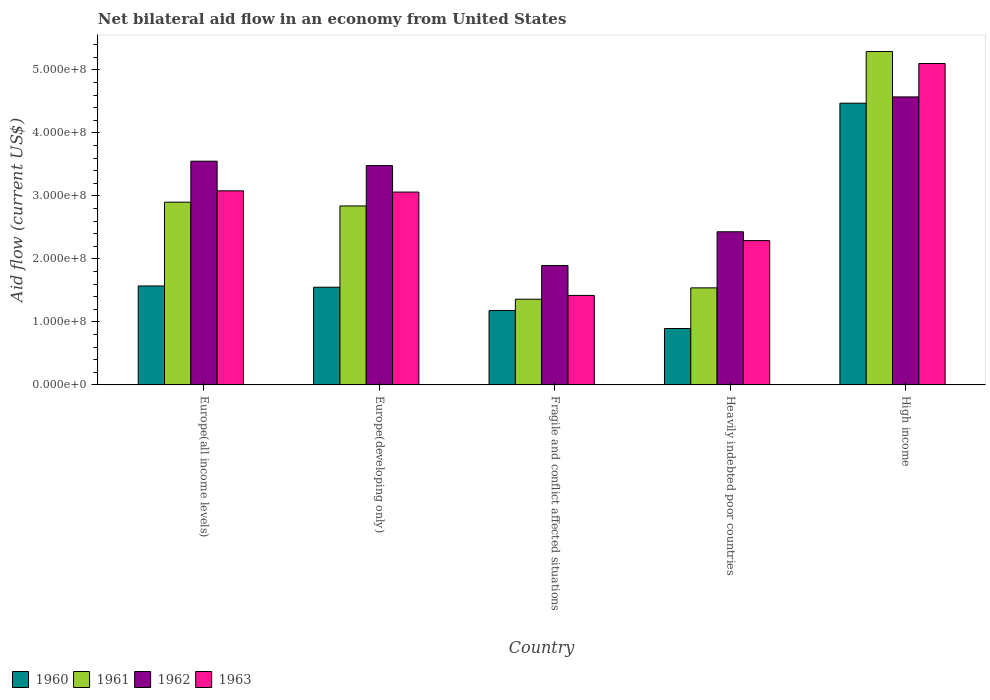How many different coloured bars are there?
Your response must be concise. 4. How many groups of bars are there?
Give a very brief answer. 5. Are the number of bars on each tick of the X-axis equal?
Ensure brevity in your answer.  Yes. How many bars are there on the 3rd tick from the right?
Offer a terse response. 4. What is the label of the 1st group of bars from the left?
Offer a terse response. Europe(all income levels). In how many cases, is the number of bars for a given country not equal to the number of legend labels?
Provide a succinct answer. 0. What is the net bilateral aid flow in 1960 in Fragile and conflict affected situations?
Offer a very short reply. 1.18e+08. Across all countries, what is the maximum net bilateral aid flow in 1961?
Your answer should be compact. 5.29e+08. Across all countries, what is the minimum net bilateral aid flow in 1963?
Your answer should be very brief. 1.42e+08. In which country was the net bilateral aid flow in 1961 maximum?
Offer a very short reply. High income. In which country was the net bilateral aid flow in 1960 minimum?
Keep it short and to the point. Heavily indebted poor countries. What is the total net bilateral aid flow in 1963 in the graph?
Give a very brief answer. 1.50e+09. What is the difference between the net bilateral aid flow in 1961 in Europe(all income levels) and that in Fragile and conflict affected situations?
Make the answer very short. 1.54e+08. What is the difference between the net bilateral aid flow in 1961 in Heavily indebted poor countries and the net bilateral aid flow in 1963 in High income?
Keep it short and to the point. -3.56e+08. What is the average net bilateral aid flow in 1962 per country?
Your response must be concise. 3.18e+08. What is the difference between the net bilateral aid flow of/in 1963 and net bilateral aid flow of/in 1962 in Heavily indebted poor countries?
Offer a terse response. -1.40e+07. What is the ratio of the net bilateral aid flow in 1961 in Fragile and conflict affected situations to that in Heavily indebted poor countries?
Offer a very short reply. 0.88. What is the difference between the highest and the second highest net bilateral aid flow in 1963?
Provide a short and direct response. 2.02e+08. What is the difference between the highest and the lowest net bilateral aid flow in 1961?
Give a very brief answer. 3.93e+08. Is it the case that in every country, the sum of the net bilateral aid flow in 1961 and net bilateral aid flow in 1960 is greater than the sum of net bilateral aid flow in 1963 and net bilateral aid flow in 1962?
Your answer should be very brief. No. What does the 1st bar from the right in Fragile and conflict affected situations represents?
Offer a terse response. 1963. Are all the bars in the graph horizontal?
Keep it short and to the point. No. What is the difference between two consecutive major ticks on the Y-axis?
Ensure brevity in your answer.  1.00e+08. Does the graph contain any zero values?
Offer a terse response. No. How many legend labels are there?
Make the answer very short. 4. How are the legend labels stacked?
Offer a very short reply. Horizontal. What is the title of the graph?
Provide a short and direct response. Net bilateral aid flow in an economy from United States. Does "1981" appear as one of the legend labels in the graph?
Offer a terse response. No. What is the label or title of the X-axis?
Make the answer very short. Country. What is the label or title of the Y-axis?
Provide a succinct answer. Aid flow (current US$). What is the Aid flow (current US$) of 1960 in Europe(all income levels)?
Your answer should be compact. 1.57e+08. What is the Aid flow (current US$) in 1961 in Europe(all income levels)?
Ensure brevity in your answer.  2.90e+08. What is the Aid flow (current US$) of 1962 in Europe(all income levels)?
Keep it short and to the point. 3.55e+08. What is the Aid flow (current US$) of 1963 in Europe(all income levels)?
Offer a terse response. 3.08e+08. What is the Aid flow (current US$) in 1960 in Europe(developing only)?
Provide a short and direct response. 1.55e+08. What is the Aid flow (current US$) in 1961 in Europe(developing only)?
Your response must be concise. 2.84e+08. What is the Aid flow (current US$) in 1962 in Europe(developing only)?
Your response must be concise. 3.48e+08. What is the Aid flow (current US$) of 1963 in Europe(developing only)?
Offer a terse response. 3.06e+08. What is the Aid flow (current US$) in 1960 in Fragile and conflict affected situations?
Provide a succinct answer. 1.18e+08. What is the Aid flow (current US$) in 1961 in Fragile and conflict affected situations?
Keep it short and to the point. 1.36e+08. What is the Aid flow (current US$) in 1962 in Fragile and conflict affected situations?
Your response must be concise. 1.90e+08. What is the Aid flow (current US$) in 1963 in Fragile and conflict affected situations?
Give a very brief answer. 1.42e+08. What is the Aid flow (current US$) in 1960 in Heavily indebted poor countries?
Provide a succinct answer. 8.95e+07. What is the Aid flow (current US$) of 1961 in Heavily indebted poor countries?
Your response must be concise. 1.54e+08. What is the Aid flow (current US$) of 1962 in Heavily indebted poor countries?
Offer a very short reply. 2.43e+08. What is the Aid flow (current US$) in 1963 in Heavily indebted poor countries?
Offer a very short reply. 2.29e+08. What is the Aid flow (current US$) in 1960 in High income?
Keep it short and to the point. 4.47e+08. What is the Aid flow (current US$) in 1961 in High income?
Ensure brevity in your answer.  5.29e+08. What is the Aid flow (current US$) in 1962 in High income?
Give a very brief answer. 4.57e+08. What is the Aid flow (current US$) of 1963 in High income?
Your answer should be very brief. 5.10e+08. Across all countries, what is the maximum Aid flow (current US$) of 1960?
Keep it short and to the point. 4.47e+08. Across all countries, what is the maximum Aid flow (current US$) in 1961?
Keep it short and to the point. 5.29e+08. Across all countries, what is the maximum Aid flow (current US$) of 1962?
Provide a short and direct response. 4.57e+08. Across all countries, what is the maximum Aid flow (current US$) of 1963?
Your response must be concise. 5.10e+08. Across all countries, what is the minimum Aid flow (current US$) in 1960?
Offer a very short reply. 8.95e+07. Across all countries, what is the minimum Aid flow (current US$) in 1961?
Provide a succinct answer. 1.36e+08. Across all countries, what is the minimum Aid flow (current US$) in 1962?
Ensure brevity in your answer.  1.90e+08. Across all countries, what is the minimum Aid flow (current US$) of 1963?
Provide a short and direct response. 1.42e+08. What is the total Aid flow (current US$) of 1960 in the graph?
Give a very brief answer. 9.67e+08. What is the total Aid flow (current US$) in 1961 in the graph?
Your response must be concise. 1.39e+09. What is the total Aid flow (current US$) of 1962 in the graph?
Keep it short and to the point. 1.59e+09. What is the total Aid flow (current US$) of 1963 in the graph?
Your answer should be compact. 1.50e+09. What is the difference between the Aid flow (current US$) of 1962 in Europe(all income levels) and that in Europe(developing only)?
Ensure brevity in your answer.  7.00e+06. What is the difference between the Aid flow (current US$) in 1963 in Europe(all income levels) and that in Europe(developing only)?
Give a very brief answer. 2.00e+06. What is the difference between the Aid flow (current US$) of 1960 in Europe(all income levels) and that in Fragile and conflict affected situations?
Offer a terse response. 3.90e+07. What is the difference between the Aid flow (current US$) of 1961 in Europe(all income levels) and that in Fragile and conflict affected situations?
Provide a succinct answer. 1.54e+08. What is the difference between the Aid flow (current US$) in 1962 in Europe(all income levels) and that in Fragile and conflict affected situations?
Your answer should be compact. 1.66e+08. What is the difference between the Aid flow (current US$) in 1963 in Europe(all income levels) and that in Fragile and conflict affected situations?
Offer a terse response. 1.66e+08. What is the difference between the Aid flow (current US$) of 1960 in Europe(all income levels) and that in Heavily indebted poor countries?
Keep it short and to the point. 6.75e+07. What is the difference between the Aid flow (current US$) in 1961 in Europe(all income levels) and that in Heavily indebted poor countries?
Your answer should be very brief. 1.36e+08. What is the difference between the Aid flow (current US$) in 1962 in Europe(all income levels) and that in Heavily indebted poor countries?
Give a very brief answer. 1.12e+08. What is the difference between the Aid flow (current US$) of 1963 in Europe(all income levels) and that in Heavily indebted poor countries?
Provide a succinct answer. 7.90e+07. What is the difference between the Aid flow (current US$) of 1960 in Europe(all income levels) and that in High income?
Keep it short and to the point. -2.90e+08. What is the difference between the Aid flow (current US$) of 1961 in Europe(all income levels) and that in High income?
Give a very brief answer. -2.39e+08. What is the difference between the Aid flow (current US$) of 1962 in Europe(all income levels) and that in High income?
Provide a succinct answer. -1.02e+08. What is the difference between the Aid flow (current US$) in 1963 in Europe(all income levels) and that in High income?
Your answer should be compact. -2.02e+08. What is the difference between the Aid flow (current US$) in 1960 in Europe(developing only) and that in Fragile and conflict affected situations?
Your answer should be compact. 3.70e+07. What is the difference between the Aid flow (current US$) of 1961 in Europe(developing only) and that in Fragile and conflict affected situations?
Ensure brevity in your answer.  1.48e+08. What is the difference between the Aid flow (current US$) of 1962 in Europe(developing only) and that in Fragile and conflict affected situations?
Your response must be concise. 1.58e+08. What is the difference between the Aid flow (current US$) in 1963 in Europe(developing only) and that in Fragile and conflict affected situations?
Give a very brief answer. 1.64e+08. What is the difference between the Aid flow (current US$) of 1960 in Europe(developing only) and that in Heavily indebted poor countries?
Provide a succinct answer. 6.55e+07. What is the difference between the Aid flow (current US$) of 1961 in Europe(developing only) and that in Heavily indebted poor countries?
Give a very brief answer. 1.30e+08. What is the difference between the Aid flow (current US$) in 1962 in Europe(developing only) and that in Heavily indebted poor countries?
Your response must be concise. 1.05e+08. What is the difference between the Aid flow (current US$) in 1963 in Europe(developing only) and that in Heavily indebted poor countries?
Give a very brief answer. 7.70e+07. What is the difference between the Aid flow (current US$) in 1960 in Europe(developing only) and that in High income?
Keep it short and to the point. -2.92e+08. What is the difference between the Aid flow (current US$) of 1961 in Europe(developing only) and that in High income?
Give a very brief answer. -2.45e+08. What is the difference between the Aid flow (current US$) of 1962 in Europe(developing only) and that in High income?
Your answer should be compact. -1.09e+08. What is the difference between the Aid flow (current US$) in 1963 in Europe(developing only) and that in High income?
Your answer should be very brief. -2.04e+08. What is the difference between the Aid flow (current US$) in 1960 in Fragile and conflict affected situations and that in Heavily indebted poor countries?
Your response must be concise. 2.85e+07. What is the difference between the Aid flow (current US$) of 1961 in Fragile and conflict affected situations and that in Heavily indebted poor countries?
Ensure brevity in your answer.  -1.80e+07. What is the difference between the Aid flow (current US$) of 1962 in Fragile and conflict affected situations and that in Heavily indebted poor countries?
Provide a succinct answer. -5.35e+07. What is the difference between the Aid flow (current US$) in 1963 in Fragile and conflict affected situations and that in Heavily indebted poor countries?
Provide a short and direct response. -8.70e+07. What is the difference between the Aid flow (current US$) in 1960 in Fragile and conflict affected situations and that in High income?
Provide a succinct answer. -3.29e+08. What is the difference between the Aid flow (current US$) in 1961 in Fragile and conflict affected situations and that in High income?
Keep it short and to the point. -3.93e+08. What is the difference between the Aid flow (current US$) in 1962 in Fragile and conflict affected situations and that in High income?
Make the answer very short. -2.68e+08. What is the difference between the Aid flow (current US$) in 1963 in Fragile and conflict affected situations and that in High income?
Offer a very short reply. -3.68e+08. What is the difference between the Aid flow (current US$) in 1960 in Heavily indebted poor countries and that in High income?
Make the answer very short. -3.57e+08. What is the difference between the Aid flow (current US$) of 1961 in Heavily indebted poor countries and that in High income?
Your response must be concise. -3.75e+08. What is the difference between the Aid flow (current US$) of 1962 in Heavily indebted poor countries and that in High income?
Provide a succinct answer. -2.14e+08. What is the difference between the Aid flow (current US$) of 1963 in Heavily indebted poor countries and that in High income?
Provide a succinct answer. -2.81e+08. What is the difference between the Aid flow (current US$) of 1960 in Europe(all income levels) and the Aid flow (current US$) of 1961 in Europe(developing only)?
Offer a very short reply. -1.27e+08. What is the difference between the Aid flow (current US$) in 1960 in Europe(all income levels) and the Aid flow (current US$) in 1962 in Europe(developing only)?
Ensure brevity in your answer.  -1.91e+08. What is the difference between the Aid flow (current US$) of 1960 in Europe(all income levels) and the Aid flow (current US$) of 1963 in Europe(developing only)?
Your answer should be very brief. -1.49e+08. What is the difference between the Aid flow (current US$) in 1961 in Europe(all income levels) and the Aid flow (current US$) in 1962 in Europe(developing only)?
Your answer should be compact. -5.80e+07. What is the difference between the Aid flow (current US$) of 1961 in Europe(all income levels) and the Aid flow (current US$) of 1963 in Europe(developing only)?
Your response must be concise. -1.60e+07. What is the difference between the Aid flow (current US$) of 1962 in Europe(all income levels) and the Aid flow (current US$) of 1963 in Europe(developing only)?
Your response must be concise. 4.90e+07. What is the difference between the Aid flow (current US$) in 1960 in Europe(all income levels) and the Aid flow (current US$) in 1961 in Fragile and conflict affected situations?
Keep it short and to the point. 2.10e+07. What is the difference between the Aid flow (current US$) of 1960 in Europe(all income levels) and the Aid flow (current US$) of 1962 in Fragile and conflict affected situations?
Your answer should be compact. -3.25e+07. What is the difference between the Aid flow (current US$) in 1960 in Europe(all income levels) and the Aid flow (current US$) in 1963 in Fragile and conflict affected situations?
Offer a very short reply. 1.50e+07. What is the difference between the Aid flow (current US$) in 1961 in Europe(all income levels) and the Aid flow (current US$) in 1962 in Fragile and conflict affected situations?
Keep it short and to the point. 1.00e+08. What is the difference between the Aid flow (current US$) of 1961 in Europe(all income levels) and the Aid flow (current US$) of 1963 in Fragile and conflict affected situations?
Provide a succinct answer. 1.48e+08. What is the difference between the Aid flow (current US$) in 1962 in Europe(all income levels) and the Aid flow (current US$) in 1963 in Fragile and conflict affected situations?
Offer a terse response. 2.13e+08. What is the difference between the Aid flow (current US$) in 1960 in Europe(all income levels) and the Aid flow (current US$) in 1961 in Heavily indebted poor countries?
Provide a succinct answer. 3.00e+06. What is the difference between the Aid flow (current US$) in 1960 in Europe(all income levels) and the Aid flow (current US$) in 1962 in Heavily indebted poor countries?
Ensure brevity in your answer.  -8.60e+07. What is the difference between the Aid flow (current US$) of 1960 in Europe(all income levels) and the Aid flow (current US$) of 1963 in Heavily indebted poor countries?
Your response must be concise. -7.20e+07. What is the difference between the Aid flow (current US$) of 1961 in Europe(all income levels) and the Aid flow (current US$) of 1962 in Heavily indebted poor countries?
Your response must be concise. 4.70e+07. What is the difference between the Aid flow (current US$) in 1961 in Europe(all income levels) and the Aid flow (current US$) in 1963 in Heavily indebted poor countries?
Your response must be concise. 6.10e+07. What is the difference between the Aid flow (current US$) in 1962 in Europe(all income levels) and the Aid flow (current US$) in 1963 in Heavily indebted poor countries?
Give a very brief answer. 1.26e+08. What is the difference between the Aid flow (current US$) of 1960 in Europe(all income levels) and the Aid flow (current US$) of 1961 in High income?
Give a very brief answer. -3.72e+08. What is the difference between the Aid flow (current US$) of 1960 in Europe(all income levels) and the Aid flow (current US$) of 1962 in High income?
Give a very brief answer. -3.00e+08. What is the difference between the Aid flow (current US$) in 1960 in Europe(all income levels) and the Aid flow (current US$) in 1963 in High income?
Keep it short and to the point. -3.53e+08. What is the difference between the Aid flow (current US$) of 1961 in Europe(all income levels) and the Aid flow (current US$) of 1962 in High income?
Ensure brevity in your answer.  -1.67e+08. What is the difference between the Aid flow (current US$) in 1961 in Europe(all income levels) and the Aid flow (current US$) in 1963 in High income?
Keep it short and to the point. -2.20e+08. What is the difference between the Aid flow (current US$) in 1962 in Europe(all income levels) and the Aid flow (current US$) in 1963 in High income?
Offer a very short reply. -1.55e+08. What is the difference between the Aid flow (current US$) in 1960 in Europe(developing only) and the Aid flow (current US$) in 1961 in Fragile and conflict affected situations?
Give a very brief answer. 1.90e+07. What is the difference between the Aid flow (current US$) of 1960 in Europe(developing only) and the Aid flow (current US$) of 1962 in Fragile and conflict affected situations?
Provide a short and direct response. -3.45e+07. What is the difference between the Aid flow (current US$) in 1960 in Europe(developing only) and the Aid flow (current US$) in 1963 in Fragile and conflict affected situations?
Provide a short and direct response. 1.30e+07. What is the difference between the Aid flow (current US$) in 1961 in Europe(developing only) and the Aid flow (current US$) in 1962 in Fragile and conflict affected situations?
Provide a succinct answer. 9.45e+07. What is the difference between the Aid flow (current US$) in 1961 in Europe(developing only) and the Aid flow (current US$) in 1963 in Fragile and conflict affected situations?
Ensure brevity in your answer.  1.42e+08. What is the difference between the Aid flow (current US$) of 1962 in Europe(developing only) and the Aid flow (current US$) of 1963 in Fragile and conflict affected situations?
Offer a terse response. 2.06e+08. What is the difference between the Aid flow (current US$) in 1960 in Europe(developing only) and the Aid flow (current US$) in 1962 in Heavily indebted poor countries?
Your answer should be very brief. -8.80e+07. What is the difference between the Aid flow (current US$) in 1960 in Europe(developing only) and the Aid flow (current US$) in 1963 in Heavily indebted poor countries?
Offer a terse response. -7.40e+07. What is the difference between the Aid flow (current US$) of 1961 in Europe(developing only) and the Aid flow (current US$) of 1962 in Heavily indebted poor countries?
Offer a terse response. 4.10e+07. What is the difference between the Aid flow (current US$) in 1961 in Europe(developing only) and the Aid flow (current US$) in 1963 in Heavily indebted poor countries?
Offer a terse response. 5.50e+07. What is the difference between the Aid flow (current US$) of 1962 in Europe(developing only) and the Aid flow (current US$) of 1963 in Heavily indebted poor countries?
Give a very brief answer. 1.19e+08. What is the difference between the Aid flow (current US$) in 1960 in Europe(developing only) and the Aid flow (current US$) in 1961 in High income?
Your answer should be compact. -3.74e+08. What is the difference between the Aid flow (current US$) in 1960 in Europe(developing only) and the Aid flow (current US$) in 1962 in High income?
Your answer should be compact. -3.02e+08. What is the difference between the Aid flow (current US$) of 1960 in Europe(developing only) and the Aid flow (current US$) of 1963 in High income?
Your answer should be very brief. -3.55e+08. What is the difference between the Aid flow (current US$) in 1961 in Europe(developing only) and the Aid flow (current US$) in 1962 in High income?
Give a very brief answer. -1.73e+08. What is the difference between the Aid flow (current US$) in 1961 in Europe(developing only) and the Aid flow (current US$) in 1963 in High income?
Give a very brief answer. -2.26e+08. What is the difference between the Aid flow (current US$) in 1962 in Europe(developing only) and the Aid flow (current US$) in 1963 in High income?
Ensure brevity in your answer.  -1.62e+08. What is the difference between the Aid flow (current US$) of 1960 in Fragile and conflict affected situations and the Aid flow (current US$) of 1961 in Heavily indebted poor countries?
Offer a very short reply. -3.60e+07. What is the difference between the Aid flow (current US$) in 1960 in Fragile and conflict affected situations and the Aid flow (current US$) in 1962 in Heavily indebted poor countries?
Your answer should be very brief. -1.25e+08. What is the difference between the Aid flow (current US$) in 1960 in Fragile and conflict affected situations and the Aid flow (current US$) in 1963 in Heavily indebted poor countries?
Give a very brief answer. -1.11e+08. What is the difference between the Aid flow (current US$) of 1961 in Fragile and conflict affected situations and the Aid flow (current US$) of 1962 in Heavily indebted poor countries?
Give a very brief answer. -1.07e+08. What is the difference between the Aid flow (current US$) in 1961 in Fragile and conflict affected situations and the Aid flow (current US$) in 1963 in Heavily indebted poor countries?
Your answer should be very brief. -9.30e+07. What is the difference between the Aid flow (current US$) of 1962 in Fragile and conflict affected situations and the Aid flow (current US$) of 1963 in Heavily indebted poor countries?
Ensure brevity in your answer.  -3.95e+07. What is the difference between the Aid flow (current US$) in 1960 in Fragile and conflict affected situations and the Aid flow (current US$) in 1961 in High income?
Give a very brief answer. -4.11e+08. What is the difference between the Aid flow (current US$) in 1960 in Fragile and conflict affected situations and the Aid flow (current US$) in 1962 in High income?
Provide a succinct answer. -3.39e+08. What is the difference between the Aid flow (current US$) of 1960 in Fragile and conflict affected situations and the Aid flow (current US$) of 1963 in High income?
Your answer should be compact. -3.92e+08. What is the difference between the Aid flow (current US$) in 1961 in Fragile and conflict affected situations and the Aid flow (current US$) in 1962 in High income?
Give a very brief answer. -3.21e+08. What is the difference between the Aid flow (current US$) in 1961 in Fragile and conflict affected situations and the Aid flow (current US$) in 1963 in High income?
Ensure brevity in your answer.  -3.74e+08. What is the difference between the Aid flow (current US$) of 1962 in Fragile and conflict affected situations and the Aid flow (current US$) of 1963 in High income?
Provide a succinct answer. -3.20e+08. What is the difference between the Aid flow (current US$) in 1960 in Heavily indebted poor countries and the Aid flow (current US$) in 1961 in High income?
Your response must be concise. -4.39e+08. What is the difference between the Aid flow (current US$) of 1960 in Heavily indebted poor countries and the Aid flow (current US$) of 1962 in High income?
Provide a succinct answer. -3.67e+08. What is the difference between the Aid flow (current US$) of 1960 in Heavily indebted poor countries and the Aid flow (current US$) of 1963 in High income?
Your answer should be compact. -4.20e+08. What is the difference between the Aid flow (current US$) in 1961 in Heavily indebted poor countries and the Aid flow (current US$) in 1962 in High income?
Offer a very short reply. -3.03e+08. What is the difference between the Aid flow (current US$) in 1961 in Heavily indebted poor countries and the Aid flow (current US$) in 1963 in High income?
Provide a short and direct response. -3.56e+08. What is the difference between the Aid flow (current US$) of 1962 in Heavily indebted poor countries and the Aid flow (current US$) of 1963 in High income?
Offer a very short reply. -2.67e+08. What is the average Aid flow (current US$) in 1960 per country?
Provide a short and direct response. 1.93e+08. What is the average Aid flow (current US$) of 1961 per country?
Keep it short and to the point. 2.79e+08. What is the average Aid flow (current US$) of 1962 per country?
Provide a short and direct response. 3.18e+08. What is the average Aid flow (current US$) in 1963 per country?
Offer a terse response. 2.99e+08. What is the difference between the Aid flow (current US$) of 1960 and Aid flow (current US$) of 1961 in Europe(all income levels)?
Offer a terse response. -1.33e+08. What is the difference between the Aid flow (current US$) in 1960 and Aid flow (current US$) in 1962 in Europe(all income levels)?
Give a very brief answer. -1.98e+08. What is the difference between the Aid flow (current US$) of 1960 and Aid flow (current US$) of 1963 in Europe(all income levels)?
Your answer should be very brief. -1.51e+08. What is the difference between the Aid flow (current US$) of 1961 and Aid flow (current US$) of 1962 in Europe(all income levels)?
Give a very brief answer. -6.50e+07. What is the difference between the Aid flow (current US$) in 1961 and Aid flow (current US$) in 1963 in Europe(all income levels)?
Your answer should be very brief. -1.80e+07. What is the difference between the Aid flow (current US$) of 1962 and Aid flow (current US$) of 1963 in Europe(all income levels)?
Offer a terse response. 4.70e+07. What is the difference between the Aid flow (current US$) of 1960 and Aid flow (current US$) of 1961 in Europe(developing only)?
Offer a very short reply. -1.29e+08. What is the difference between the Aid flow (current US$) in 1960 and Aid flow (current US$) in 1962 in Europe(developing only)?
Provide a short and direct response. -1.93e+08. What is the difference between the Aid flow (current US$) in 1960 and Aid flow (current US$) in 1963 in Europe(developing only)?
Offer a very short reply. -1.51e+08. What is the difference between the Aid flow (current US$) of 1961 and Aid flow (current US$) of 1962 in Europe(developing only)?
Make the answer very short. -6.40e+07. What is the difference between the Aid flow (current US$) in 1961 and Aid flow (current US$) in 1963 in Europe(developing only)?
Your answer should be very brief. -2.20e+07. What is the difference between the Aid flow (current US$) of 1962 and Aid flow (current US$) of 1963 in Europe(developing only)?
Your response must be concise. 4.20e+07. What is the difference between the Aid flow (current US$) in 1960 and Aid flow (current US$) in 1961 in Fragile and conflict affected situations?
Provide a succinct answer. -1.80e+07. What is the difference between the Aid flow (current US$) of 1960 and Aid flow (current US$) of 1962 in Fragile and conflict affected situations?
Keep it short and to the point. -7.15e+07. What is the difference between the Aid flow (current US$) in 1960 and Aid flow (current US$) in 1963 in Fragile and conflict affected situations?
Provide a short and direct response. -2.40e+07. What is the difference between the Aid flow (current US$) of 1961 and Aid flow (current US$) of 1962 in Fragile and conflict affected situations?
Make the answer very short. -5.35e+07. What is the difference between the Aid flow (current US$) of 1961 and Aid flow (current US$) of 1963 in Fragile and conflict affected situations?
Your answer should be very brief. -6.00e+06. What is the difference between the Aid flow (current US$) of 1962 and Aid flow (current US$) of 1963 in Fragile and conflict affected situations?
Give a very brief answer. 4.75e+07. What is the difference between the Aid flow (current US$) in 1960 and Aid flow (current US$) in 1961 in Heavily indebted poor countries?
Give a very brief answer. -6.45e+07. What is the difference between the Aid flow (current US$) of 1960 and Aid flow (current US$) of 1962 in Heavily indebted poor countries?
Provide a short and direct response. -1.53e+08. What is the difference between the Aid flow (current US$) of 1960 and Aid flow (current US$) of 1963 in Heavily indebted poor countries?
Keep it short and to the point. -1.39e+08. What is the difference between the Aid flow (current US$) in 1961 and Aid flow (current US$) in 1962 in Heavily indebted poor countries?
Offer a terse response. -8.90e+07. What is the difference between the Aid flow (current US$) of 1961 and Aid flow (current US$) of 1963 in Heavily indebted poor countries?
Your response must be concise. -7.50e+07. What is the difference between the Aid flow (current US$) of 1962 and Aid flow (current US$) of 1963 in Heavily indebted poor countries?
Provide a short and direct response. 1.40e+07. What is the difference between the Aid flow (current US$) of 1960 and Aid flow (current US$) of 1961 in High income?
Offer a very short reply. -8.20e+07. What is the difference between the Aid flow (current US$) in 1960 and Aid flow (current US$) in 1962 in High income?
Offer a very short reply. -1.00e+07. What is the difference between the Aid flow (current US$) in 1960 and Aid flow (current US$) in 1963 in High income?
Your answer should be very brief. -6.30e+07. What is the difference between the Aid flow (current US$) of 1961 and Aid flow (current US$) of 1962 in High income?
Give a very brief answer. 7.20e+07. What is the difference between the Aid flow (current US$) in 1961 and Aid flow (current US$) in 1963 in High income?
Ensure brevity in your answer.  1.90e+07. What is the difference between the Aid flow (current US$) of 1962 and Aid flow (current US$) of 1963 in High income?
Provide a succinct answer. -5.30e+07. What is the ratio of the Aid flow (current US$) of 1960 in Europe(all income levels) to that in Europe(developing only)?
Offer a terse response. 1.01. What is the ratio of the Aid flow (current US$) in 1961 in Europe(all income levels) to that in Europe(developing only)?
Provide a short and direct response. 1.02. What is the ratio of the Aid flow (current US$) in 1962 in Europe(all income levels) to that in Europe(developing only)?
Offer a terse response. 1.02. What is the ratio of the Aid flow (current US$) in 1960 in Europe(all income levels) to that in Fragile and conflict affected situations?
Your answer should be very brief. 1.33. What is the ratio of the Aid flow (current US$) of 1961 in Europe(all income levels) to that in Fragile and conflict affected situations?
Your answer should be very brief. 2.13. What is the ratio of the Aid flow (current US$) in 1962 in Europe(all income levels) to that in Fragile and conflict affected situations?
Offer a terse response. 1.87. What is the ratio of the Aid flow (current US$) of 1963 in Europe(all income levels) to that in Fragile and conflict affected situations?
Provide a succinct answer. 2.17. What is the ratio of the Aid flow (current US$) of 1960 in Europe(all income levels) to that in Heavily indebted poor countries?
Your answer should be compact. 1.75. What is the ratio of the Aid flow (current US$) of 1961 in Europe(all income levels) to that in Heavily indebted poor countries?
Your answer should be very brief. 1.88. What is the ratio of the Aid flow (current US$) in 1962 in Europe(all income levels) to that in Heavily indebted poor countries?
Provide a short and direct response. 1.46. What is the ratio of the Aid flow (current US$) of 1963 in Europe(all income levels) to that in Heavily indebted poor countries?
Give a very brief answer. 1.34. What is the ratio of the Aid flow (current US$) of 1960 in Europe(all income levels) to that in High income?
Give a very brief answer. 0.35. What is the ratio of the Aid flow (current US$) of 1961 in Europe(all income levels) to that in High income?
Provide a short and direct response. 0.55. What is the ratio of the Aid flow (current US$) of 1962 in Europe(all income levels) to that in High income?
Your answer should be compact. 0.78. What is the ratio of the Aid flow (current US$) in 1963 in Europe(all income levels) to that in High income?
Give a very brief answer. 0.6. What is the ratio of the Aid flow (current US$) in 1960 in Europe(developing only) to that in Fragile and conflict affected situations?
Your answer should be very brief. 1.31. What is the ratio of the Aid flow (current US$) of 1961 in Europe(developing only) to that in Fragile and conflict affected situations?
Your answer should be compact. 2.09. What is the ratio of the Aid flow (current US$) in 1962 in Europe(developing only) to that in Fragile and conflict affected situations?
Offer a very short reply. 1.84. What is the ratio of the Aid flow (current US$) of 1963 in Europe(developing only) to that in Fragile and conflict affected situations?
Offer a terse response. 2.15. What is the ratio of the Aid flow (current US$) of 1960 in Europe(developing only) to that in Heavily indebted poor countries?
Your answer should be very brief. 1.73. What is the ratio of the Aid flow (current US$) of 1961 in Europe(developing only) to that in Heavily indebted poor countries?
Your answer should be compact. 1.84. What is the ratio of the Aid flow (current US$) in 1962 in Europe(developing only) to that in Heavily indebted poor countries?
Offer a terse response. 1.43. What is the ratio of the Aid flow (current US$) in 1963 in Europe(developing only) to that in Heavily indebted poor countries?
Ensure brevity in your answer.  1.34. What is the ratio of the Aid flow (current US$) of 1960 in Europe(developing only) to that in High income?
Offer a very short reply. 0.35. What is the ratio of the Aid flow (current US$) of 1961 in Europe(developing only) to that in High income?
Ensure brevity in your answer.  0.54. What is the ratio of the Aid flow (current US$) of 1962 in Europe(developing only) to that in High income?
Your answer should be compact. 0.76. What is the ratio of the Aid flow (current US$) in 1960 in Fragile and conflict affected situations to that in Heavily indebted poor countries?
Make the answer very short. 1.32. What is the ratio of the Aid flow (current US$) of 1961 in Fragile and conflict affected situations to that in Heavily indebted poor countries?
Make the answer very short. 0.88. What is the ratio of the Aid flow (current US$) of 1962 in Fragile and conflict affected situations to that in Heavily indebted poor countries?
Your answer should be very brief. 0.78. What is the ratio of the Aid flow (current US$) in 1963 in Fragile and conflict affected situations to that in Heavily indebted poor countries?
Ensure brevity in your answer.  0.62. What is the ratio of the Aid flow (current US$) in 1960 in Fragile and conflict affected situations to that in High income?
Offer a terse response. 0.26. What is the ratio of the Aid flow (current US$) in 1961 in Fragile and conflict affected situations to that in High income?
Your answer should be compact. 0.26. What is the ratio of the Aid flow (current US$) of 1962 in Fragile and conflict affected situations to that in High income?
Offer a terse response. 0.41. What is the ratio of the Aid flow (current US$) in 1963 in Fragile and conflict affected situations to that in High income?
Offer a very short reply. 0.28. What is the ratio of the Aid flow (current US$) in 1960 in Heavily indebted poor countries to that in High income?
Your response must be concise. 0.2. What is the ratio of the Aid flow (current US$) of 1961 in Heavily indebted poor countries to that in High income?
Keep it short and to the point. 0.29. What is the ratio of the Aid flow (current US$) of 1962 in Heavily indebted poor countries to that in High income?
Make the answer very short. 0.53. What is the ratio of the Aid flow (current US$) of 1963 in Heavily indebted poor countries to that in High income?
Your response must be concise. 0.45. What is the difference between the highest and the second highest Aid flow (current US$) in 1960?
Your answer should be very brief. 2.90e+08. What is the difference between the highest and the second highest Aid flow (current US$) of 1961?
Your response must be concise. 2.39e+08. What is the difference between the highest and the second highest Aid flow (current US$) of 1962?
Offer a very short reply. 1.02e+08. What is the difference between the highest and the second highest Aid flow (current US$) in 1963?
Offer a terse response. 2.02e+08. What is the difference between the highest and the lowest Aid flow (current US$) of 1960?
Keep it short and to the point. 3.57e+08. What is the difference between the highest and the lowest Aid flow (current US$) in 1961?
Offer a terse response. 3.93e+08. What is the difference between the highest and the lowest Aid flow (current US$) in 1962?
Keep it short and to the point. 2.68e+08. What is the difference between the highest and the lowest Aid flow (current US$) in 1963?
Your answer should be very brief. 3.68e+08. 